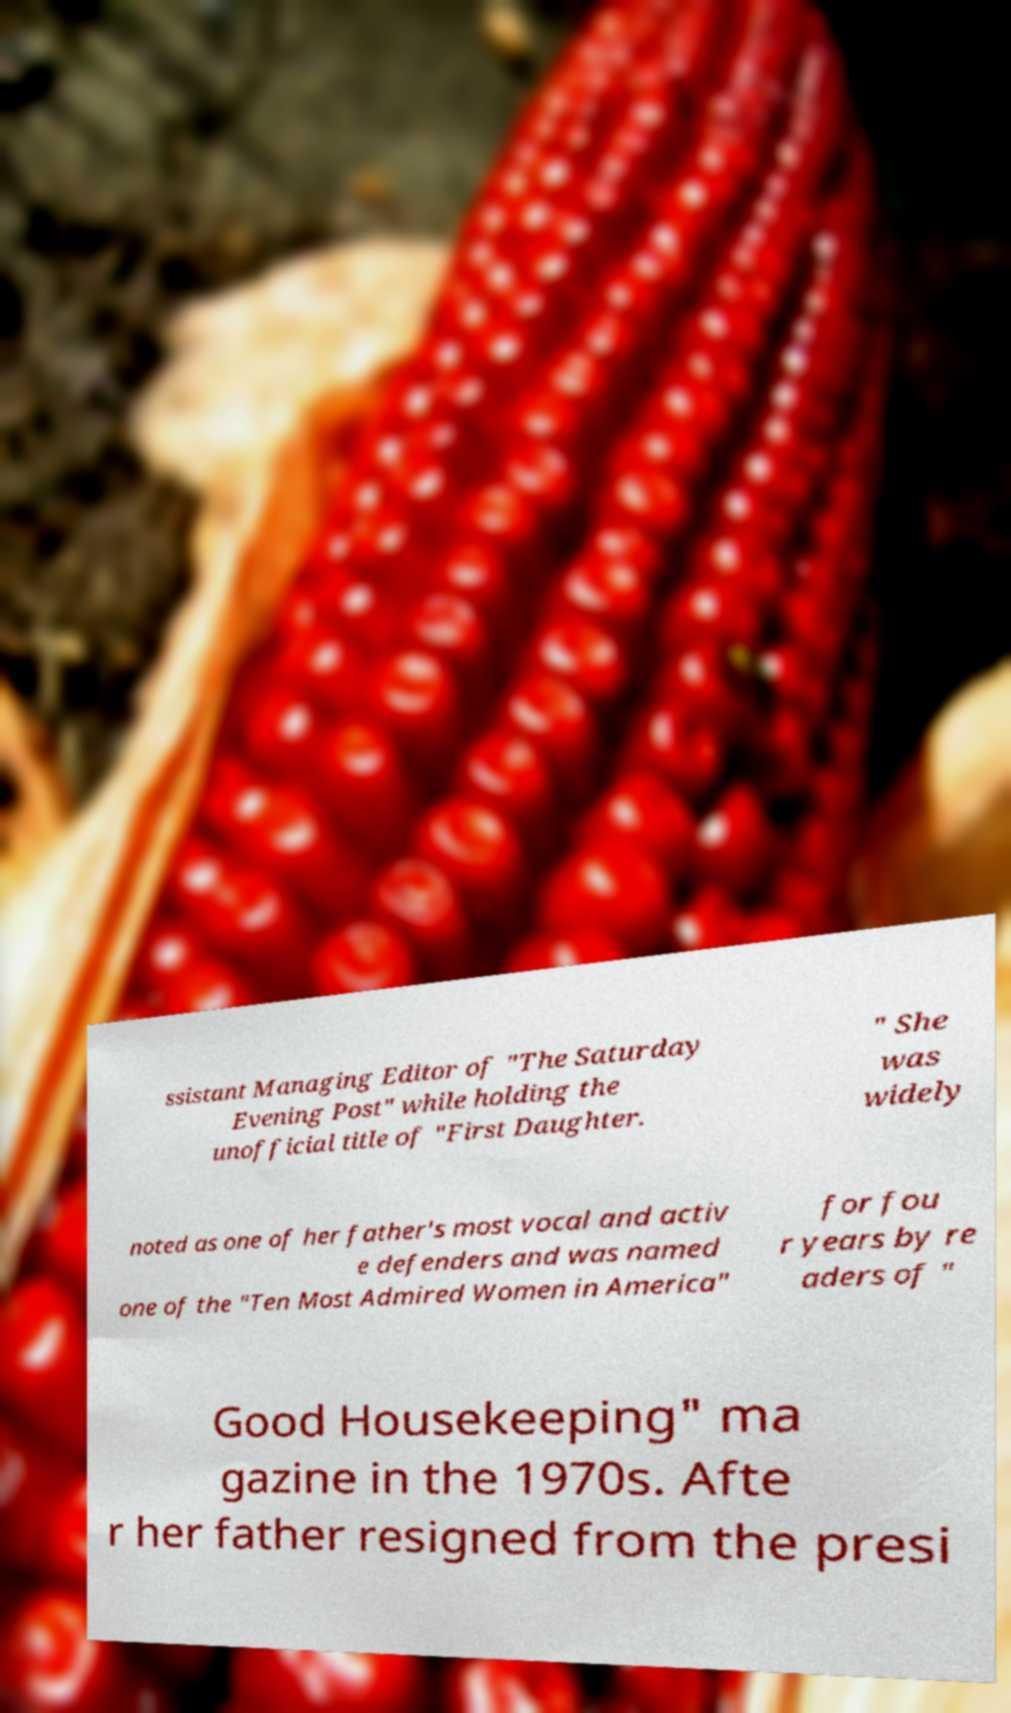What messages or text are displayed in this image? I need them in a readable, typed format. ssistant Managing Editor of "The Saturday Evening Post" while holding the unofficial title of "First Daughter. " She was widely noted as one of her father's most vocal and activ e defenders and was named one of the "Ten Most Admired Women in America" for fou r years by re aders of " Good Housekeeping" ma gazine in the 1970s. Afte r her father resigned from the presi 